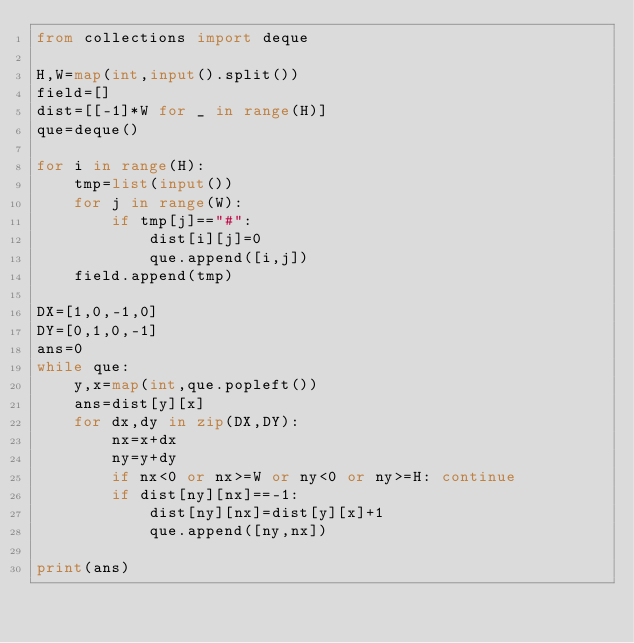Convert code to text. <code><loc_0><loc_0><loc_500><loc_500><_Python_>from collections import deque

H,W=map(int,input().split())
field=[]
dist=[[-1]*W for _ in range(H)]
que=deque()

for i in range(H):
    tmp=list(input())
    for j in range(W):
        if tmp[j]=="#":
            dist[i][j]=0
            que.append([i,j])
    field.append(tmp)

DX=[1,0,-1,0]
DY=[0,1,0,-1]
ans=0
while que:
    y,x=map(int,que.popleft())
    ans=dist[y][x]
    for dx,dy in zip(DX,DY):
        nx=x+dx
        ny=y+dy
        if nx<0 or nx>=W or ny<0 or ny>=H: continue
        if dist[ny][nx]==-1:
            dist[ny][nx]=dist[y][x]+1
            que.append([ny,nx])

print(ans)
</code> 